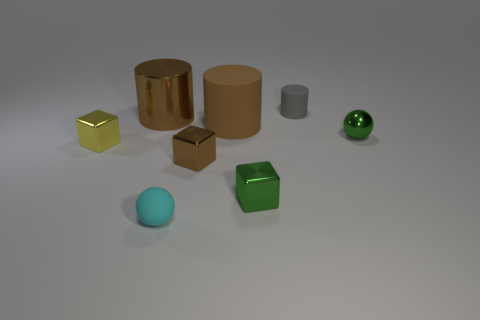Add 2 gray metallic cylinders. How many objects exist? 10 Subtract all balls. How many objects are left? 6 Add 3 big green rubber cylinders. How many big green rubber cylinders exist? 3 Subtract 1 green blocks. How many objects are left? 7 Subtract all matte things. Subtract all small green metal things. How many objects are left? 3 Add 4 tiny yellow shiny things. How many tiny yellow shiny things are left? 5 